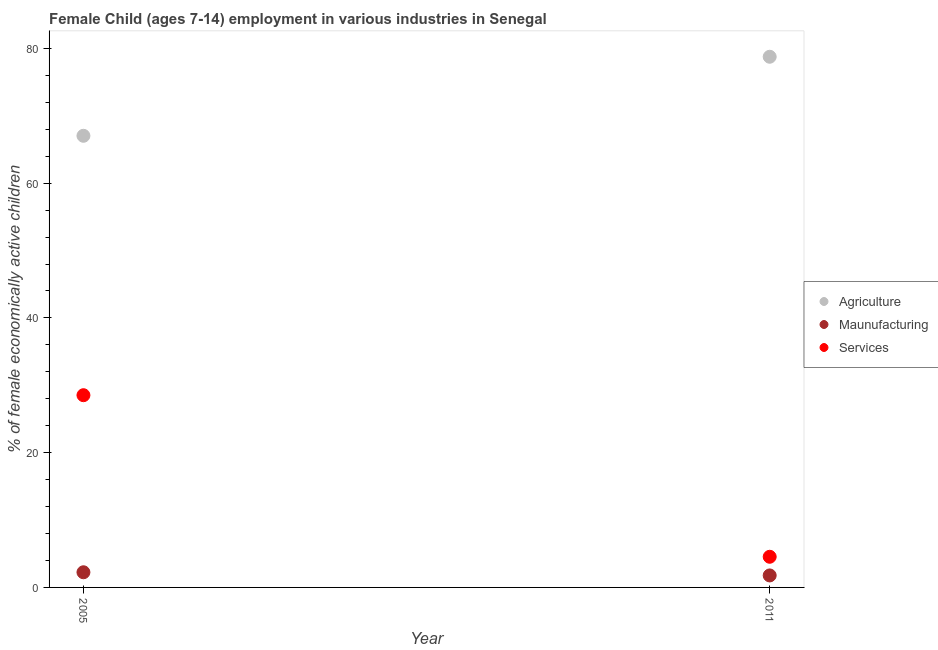Is the number of dotlines equal to the number of legend labels?
Provide a succinct answer. Yes. What is the percentage of economically active children in manufacturing in 2011?
Make the answer very short. 1.78. Across all years, what is the maximum percentage of economically active children in services?
Offer a terse response. 28.53. Across all years, what is the minimum percentage of economically active children in agriculture?
Provide a short and direct response. 67.03. What is the total percentage of economically active children in agriculture in the graph?
Your answer should be very brief. 145.79. What is the difference between the percentage of economically active children in agriculture in 2005 and that in 2011?
Keep it short and to the point. -11.73. What is the difference between the percentage of economically active children in services in 2011 and the percentage of economically active children in manufacturing in 2005?
Your answer should be compact. 2.3. What is the average percentage of economically active children in agriculture per year?
Give a very brief answer. 72.9. In the year 2011, what is the difference between the percentage of economically active children in agriculture and percentage of economically active children in manufacturing?
Offer a very short reply. 76.98. In how many years, is the percentage of economically active children in agriculture greater than 40 %?
Provide a succinct answer. 2. What is the ratio of the percentage of economically active children in manufacturing in 2005 to that in 2011?
Give a very brief answer. 1.26. Is the percentage of economically active children in services in 2005 less than that in 2011?
Make the answer very short. No. In how many years, is the percentage of economically active children in manufacturing greater than the average percentage of economically active children in manufacturing taken over all years?
Your answer should be compact. 1. Does the percentage of economically active children in manufacturing monotonically increase over the years?
Provide a succinct answer. No. How many dotlines are there?
Ensure brevity in your answer.  3. What is the difference between two consecutive major ticks on the Y-axis?
Your response must be concise. 20. Are the values on the major ticks of Y-axis written in scientific E-notation?
Provide a succinct answer. No. Does the graph contain grids?
Provide a succinct answer. No. Where does the legend appear in the graph?
Keep it short and to the point. Center right. How many legend labels are there?
Make the answer very short. 3. How are the legend labels stacked?
Give a very brief answer. Vertical. What is the title of the graph?
Keep it short and to the point. Female Child (ages 7-14) employment in various industries in Senegal. What is the label or title of the X-axis?
Your answer should be compact. Year. What is the label or title of the Y-axis?
Provide a succinct answer. % of female economically active children. What is the % of female economically active children in Agriculture in 2005?
Give a very brief answer. 67.03. What is the % of female economically active children in Maunufacturing in 2005?
Provide a succinct answer. 2.25. What is the % of female economically active children of Services in 2005?
Your answer should be very brief. 28.53. What is the % of female economically active children in Agriculture in 2011?
Give a very brief answer. 78.76. What is the % of female economically active children of Maunufacturing in 2011?
Provide a short and direct response. 1.78. What is the % of female economically active children in Services in 2011?
Provide a succinct answer. 4.55. Across all years, what is the maximum % of female economically active children of Agriculture?
Provide a succinct answer. 78.76. Across all years, what is the maximum % of female economically active children of Maunufacturing?
Ensure brevity in your answer.  2.25. Across all years, what is the maximum % of female economically active children of Services?
Provide a succinct answer. 28.53. Across all years, what is the minimum % of female economically active children of Agriculture?
Give a very brief answer. 67.03. Across all years, what is the minimum % of female economically active children of Maunufacturing?
Offer a very short reply. 1.78. Across all years, what is the minimum % of female economically active children of Services?
Keep it short and to the point. 4.55. What is the total % of female economically active children of Agriculture in the graph?
Your response must be concise. 145.79. What is the total % of female economically active children in Maunufacturing in the graph?
Provide a short and direct response. 4.03. What is the total % of female economically active children of Services in the graph?
Offer a very short reply. 33.08. What is the difference between the % of female economically active children in Agriculture in 2005 and that in 2011?
Offer a terse response. -11.73. What is the difference between the % of female economically active children of Maunufacturing in 2005 and that in 2011?
Ensure brevity in your answer.  0.47. What is the difference between the % of female economically active children in Services in 2005 and that in 2011?
Your answer should be very brief. 23.98. What is the difference between the % of female economically active children of Agriculture in 2005 and the % of female economically active children of Maunufacturing in 2011?
Ensure brevity in your answer.  65.25. What is the difference between the % of female economically active children in Agriculture in 2005 and the % of female economically active children in Services in 2011?
Ensure brevity in your answer.  62.48. What is the average % of female economically active children in Agriculture per year?
Provide a succinct answer. 72.89. What is the average % of female economically active children of Maunufacturing per year?
Offer a terse response. 2.02. What is the average % of female economically active children in Services per year?
Your response must be concise. 16.54. In the year 2005, what is the difference between the % of female economically active children in Agriculture and % of female economically active children in Maunufacturing?
Provide a succinct answer. 64.78. In the year 2005, what is the difference between the % of female economically active children of Agriculture and % of female economically active children of Services?
Ensure brevity in your answer.  38.5. In the year 2005, what is the difference between the % of female economically active children in Maunufacturing and % of female economically active children in Services?
Provide a succinct answer. -26.28. In the year 2011, what is the difference between the % of female economically active children in Agriculture and % of female economically active children in Maunufacturing?
Your response must be concise. 76.98. In the year 2011, what is the difference between the % of female economically active children in Agriculture and % of female economically active children in Services?
Your response must be concise. 74.21. In the year 2011, what is the difference between the % of female economically active children of Maunufacturing and % of female economically active children of Services?
Provide a succinct answer. -2.77. What is the ratio of the % of female economically active children of Agriculture in 2005 to that in 2011?
Provide a short and direct response. 0.85. What is the ratio of the % of female economically active children of Maunufacturing in 2005 to that in 2011?
Your answer should be very brief. 1.26. What is the ratio of the % of female economically active children in Services in 2005 to that in 2011?
Give a very brief answer. 6.27. What is the difference between the highest and the second highest % of female economically active children in Agriculture?
Offer a very short reply. 11.73. What is the difference between the highest and the second highest % of female economically active children of Maunufacturing?
Keep it short and to the point. 0.47. What is the difference between the highest and the second highest % of female economically active children of Services?
Ensure brevity in your answer.  23.98. What is the difference between the highest and the lowest % of female economically active children of Agriculture?
Offer a very short reply. 11.73. What is the difference between the highest and the lowest % of female economically active children of Maunufacturing?
Your answer should be very brief. 0.47. What is the difference between the highest and the lowest % of female economically active children of Services?
Your answer should be very brief. 23.98. 